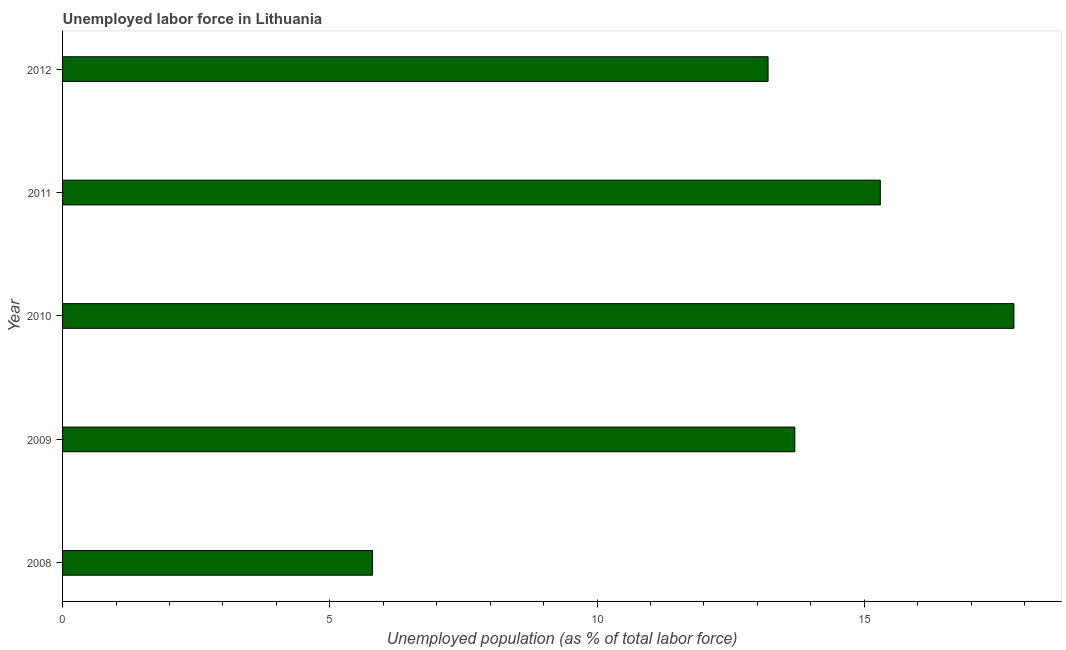Does the graph contain any zero values?
Make the answer very short. No. What is the title of the graph?
Offer a very short reply. Unemployed labor force in Lithuania. What is the label or title of the X-axis?
Offer a very short reply. Unemployed population (as % of total labor force). What is the total unemployed population in 2012?
Give a very brief answer. 13.2. Across all years, what is the maximum total unemployed population?
Make the answer very short. 17.8. Across all years, what is the minimum total unemployed population?
Your answer should be compact. 5.8. In which year was the total unemployed population maximum?
Provide a short and direct response. 2010. What is the sum of the total unemployed population?
Your answer should be very brief. 65.8. What is the difference between the total unemployed population in 2010 and 2011?
Offer a terse response. 2.5. What is the average total unemployed population per year?
Provide a succinct answer. 13.16. What is the median total unemployed population?
Ensure brevity in your answer.  13.7. What is the ratio of the total unemployed population in 2008 to that in 2012?
Make the answer very short. 0.44. Is the total unemployed population in 2008 less than that in 2010?
Ensure brevity in your answer.  Yes. Is the difference between the total unemployed population in 2009 and 2012 greater than the difference between any two years?
Your response must be concise. No. What is the difference between the highest and the lowest total unemployed population?
Provide a succinct answer. 12. How many years are there in the graph?
Make the answer very short. 5. Are the values on the major ticks of X-axis written in scientific E-notation?
Provide a short and direct response. No. What is the Unemployed population (as % of total labor force) of 2008?
Keep it short and to the point. 5.8. What is the Unemployed population (as % of total labor force) of 2009?
Make the answer very short. 13.7. What is the Unemployed population (as % of total labor force) of 2010?
Offer a terse response. 17.8. What is the Unemployed population (as % of total labor force) in 2011?
Your answer should be compact. 15.3. What is the Unemployed population (as % of total labor force) of 2012?
Offer a terse response. 13.2. What is the difference between the Unemployed population (as % of total labor force) in 2008 and 2009?
Keep it short and to the point. -7.9. What is the difference between the Unemployed population (as % of total labor force) in 2008 and 2010?
Your answer should be very brief. -12. What is the difference between the Unemployed population (as % of total labor force) in 2009 and 2011?
Provide a short and direct response. -1.6. What is the difference between the Unemployed population (as % of total labor force) in 2009 and 2012?
Provide a succinct answer. 0.5. What is the difference between the Unemployed population (as % of total labor force) in 2010 and 2011?
Your answer should be very brief. 2.5. What is the difference between the Unemployed population (as % of total labor force) in 2010 and 2012?
Your answer should be compact. 4.6. What is the ratio of the Unemployed population (as % of total labor force) in 2008 to that in 2009?
Make the answer very short. 0.42. What is the ratio of the Unemployed population (as % of total labor force) in 2008 to that in 2010?
Keep it short and to the point. 0.33. What is the ratio of the Unemployed population (as % of total labor force) in 2008 to that in 2011?
Give a very brief answer. 0.38. What is the ratio of the Unemployed population (as % of total labor force) in 2008 to that in 2012?
Give a very brief answer. 0.44. What is the ratio of the Unemployed population (as % of total labor force) in 2009 to that in 2010?
Your answer should be very brief. 0.77. What is the ratio of the Unemployed population (as % of total labor force) in 2009 to that in 2011?
Make the answer very short. 0.9. What is the ratio of the Unemployed population (as % of total labor force) in 2009 to that in 2012?
Provide a succinct answer. 1.04. What is the ratio of the Unemployed population (as % of total labor force) in 2010 to that in 2011?
Offer a very short reply. 1.16. What is the ratio of the Unemployed population (as % of total labor force) in 2010 to that in 2012?
Ensure brevity in your answer.  1.35. What is the ratio of the Unemployed population (as % of total labor force) in 2011 to that in 2012?
Your answer should be compact. 1.16. 